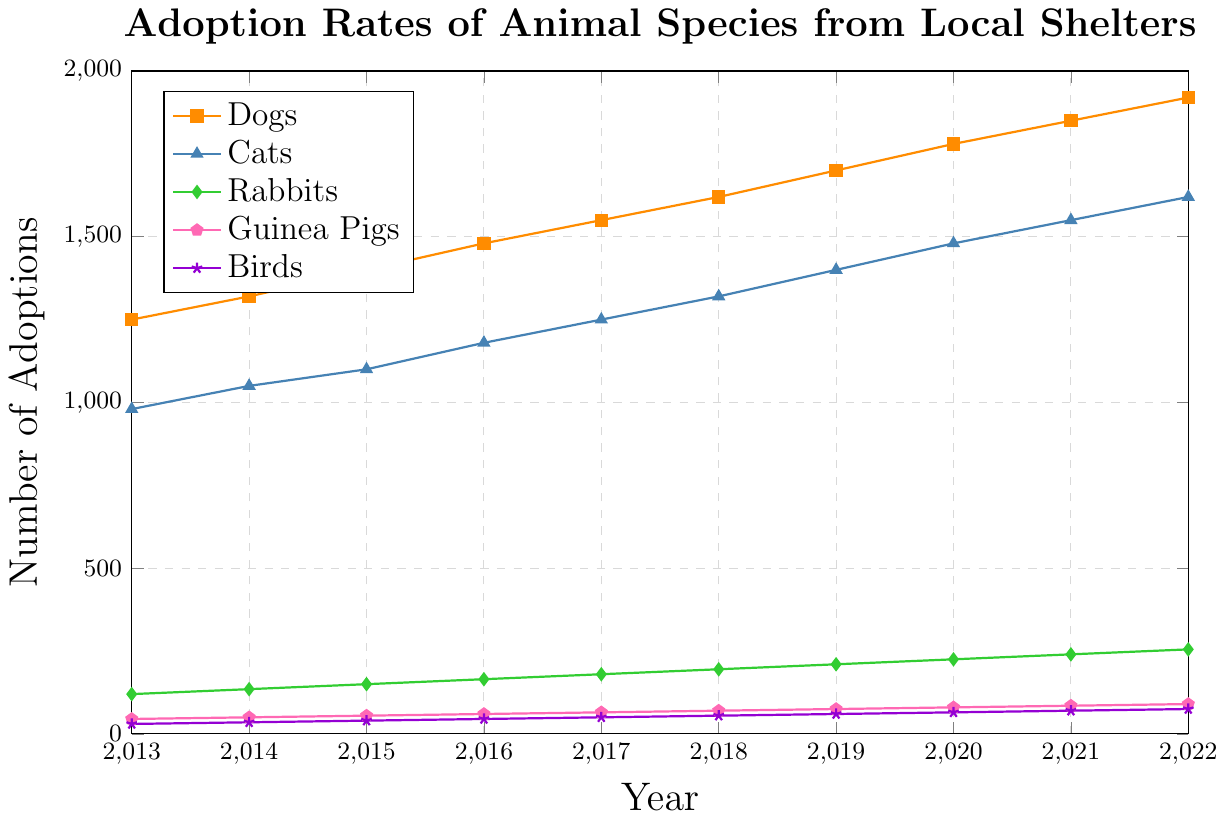Which animal species had the highest adoption rate in 2022? In 2022, the highest line on the chart corresponds to the adoption rates of Dogs, which has the highest number on the vertical axis.
Answer: Dogs Which animal species had the lowest adoption rate in 2013? In 2013, the lowest line on the chart corresponds to the adoption rates of Birds, which has the lowest number on the vertical axis.
Answer: Birds By how much did the adoption rate for Cats increase from 2013 to 2022? The adoption rate for Cats in 2013 was 980 and in 2022 it was 1620. The increase is calculated as 1620 - 980.
Answer: 640 What was the total number of Dog adoptions from 2019 to 2022? Sum the number of Dog adoptions for 2019 (1700), 2020 (1780), 2021 (1850), and 2022 (1920). Total = 1700 + 1780 + 1850 + 1920.
Answer: 7250 Which two species had the closest number of adoptions in 2017, and what is the difference between their adoption numbers? In 2017, Cats had 1250 adoptions and Dogs had 1550 adoptions. The difference is calculated as 1550 - 1250.
Answer: Cats and Dogs, 300 What is the average annual increase in Rabbit adoptions from 2013 to 2022? First calculate the total increase: 255 (in 2022) - 120 (in 2013) = 135. Then divide by the number of years (2022 - 2013 = 9). Average increase = 135 / 9.
Answer: 15 By how much did Guinea Pig adoptions increase between 2015 and 2018? The number of Guinea Pig adoptions in 2015 was 55, and in 2018 it was 70. The increase is calculated as 70 - 55.
Answer: 15 What is the trend in Bird adoptions from 2013 to 2022? Observing the chart, Bird adoptions steadily increased from 30 in 2013 to 75 in 2022.
Answer: Steady increase Which year had the highest rate of increase in Dog adoptions? To find out, compare the yearly increases: 2014 (1320 - 1250 = 70), 2015 (1400 - 1320 = 80), 2016 (1480 - 1400 = 80), 2017 (1550 - 1480 = 70), 2018 (1620 - 1550 = 70), 2019 (1700 - 1620 = 80), 2020 (1780 - 1700 = 80), 2021 (1850 - 1780 = 70), 2022 (1920 - 1850 = 70). The highest increase is seen in multiple years with an equal increase of 80.
Answer: 2015, 2016, 2019, 2020 